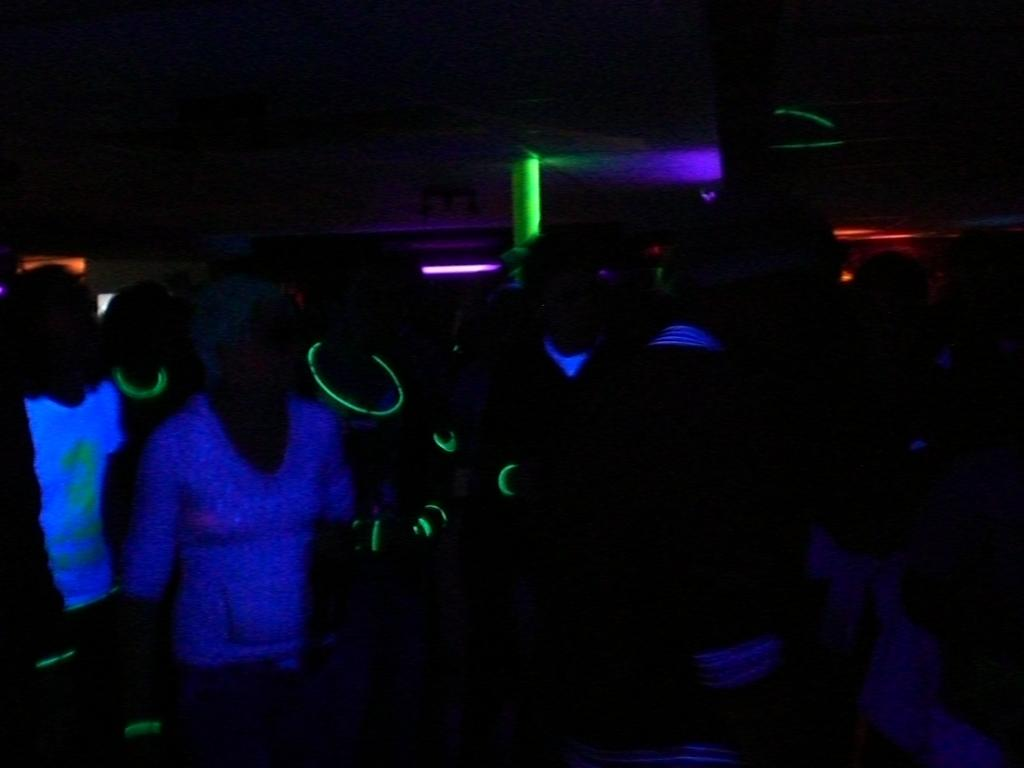Who or what can be seen in the image? There are people in the image. What structure is present in the image? There is a pole in the image. What can be seen illuminating the area in the image? There are lights in the image. What part of a building is visible in the image? The roof is visible in the image. What type of grass is growing on the pole in the image? There is no grass present on the pole in the image. 